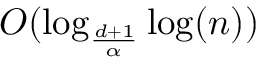Convert formula to latex. <formula><loc_0><loc_0><loc_500><loc_500>O ( \log _ { \frac { d + 1 } { \alpha } } \log ( n ) )</formula> 